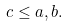Convert formula to latex. <formula><loc_0><loc_0><loc_500><loc_500>c \leq a , b .</formula> 